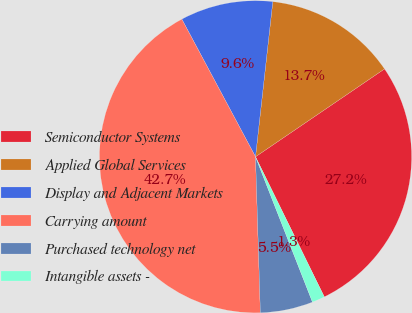Convert chart to OTSL. <chart><loc_0><loc_0><loc_500><loc_500><pie_chart><fcel>Semiconductor Systems<fcel>Applied Global Services<fcel>Display and Adjacent Markets<fcel>Carrying amount<fcel>Purchased technology net<fcel>Intangible assets -<nl><fcel>27.25%<fcel>13.72%<fcel>9.59%<fcel>42.67%<fcel>5.45%<fcel>1.32%<nl></chart> 